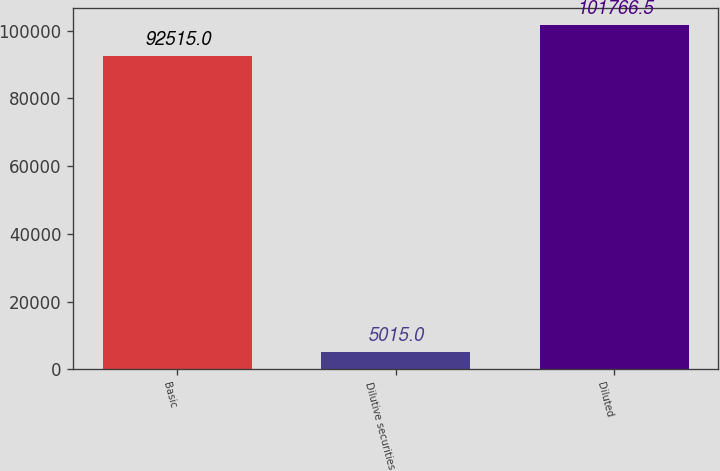Convert chart. <chart><loc_0><loc_0><loc_500><loc_500><bar_chart><fcel>Basic<fcel>Dilutive securities<fcel>Diluted<nl><fcel>92515<fcel>5015<fcel>101766<nl></chart> 